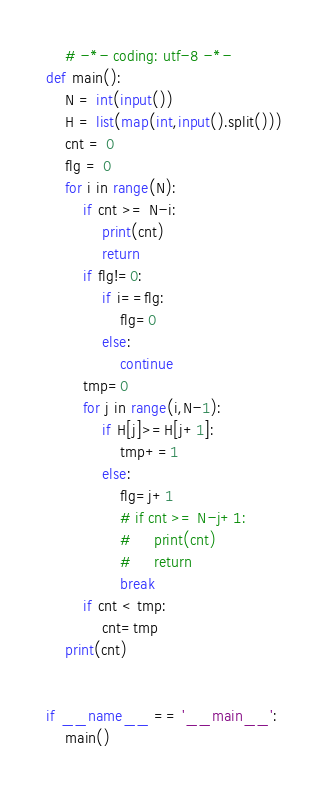<code> <loc_0><loc_0><loc_500><loc_500><_Python_>    # -*- coding: utf-8 -*-
def main():
    N = int(input())
    H = list(map(int,input().split()))
    cnt = 0
    flg = 0
    for i in range(N):
        if cnt >= N-i:
            print(cnt)
            return
        if flg!=0:
            if i==flg:
                flg=0
            else:
                continue
        tmp=0
        for j in range(i,N-1):
            if H[j]>=H[j+1]:
                tmp+=1
            else:
                flg=j+1
                # if cnt >= N-j+1:
                #     print(cnt)
                #     return
                break
        if cnt < tmp:
            cnt=tmp
    print(cnt)


if __name__ == '__main__':
    main()
</code> 